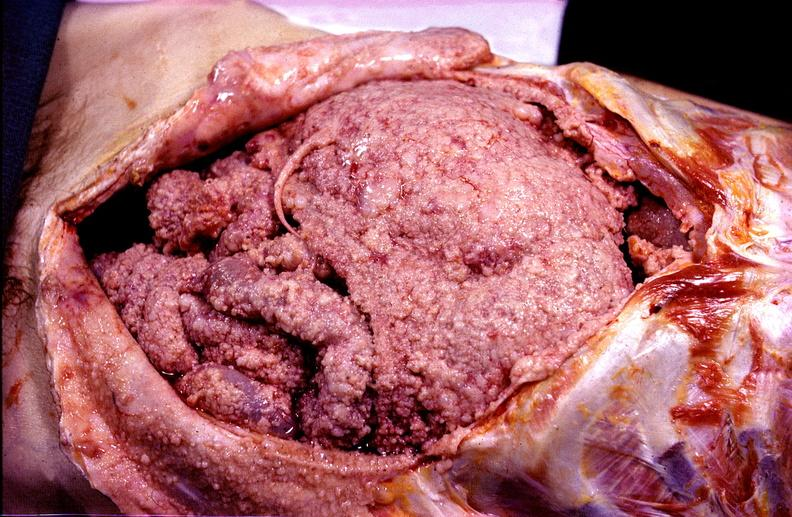where is this area in the body?
Answer the question using a single word or phrase. Abdomen 